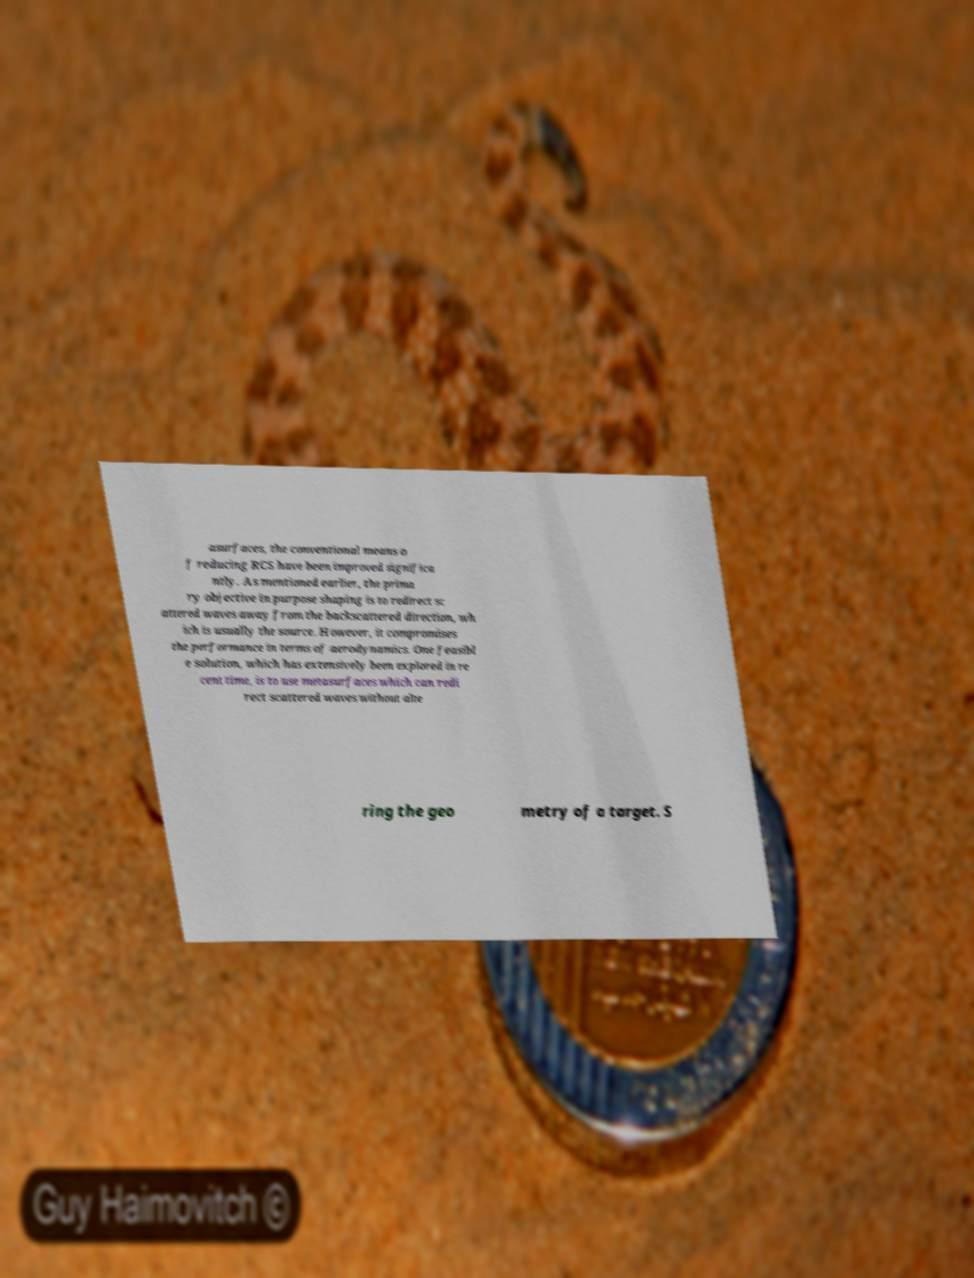Can you accurately transcribe the text from the provided image for me? asurfaces, the conventional means o f reducing RCS have been improved significa ntly. As mentioned earlier, the prima ry objective in purpose shaping is to redirect sc attered waves away from the backscattered direction, wh ich is usually the source. However, it compromises the performance in terms of aerodynamics. One feasibl e solution, which has extensively been explored in re cent time, is to use metasurfaces which can redi rect scattered waves without alte ring the geo metry of a target. S 